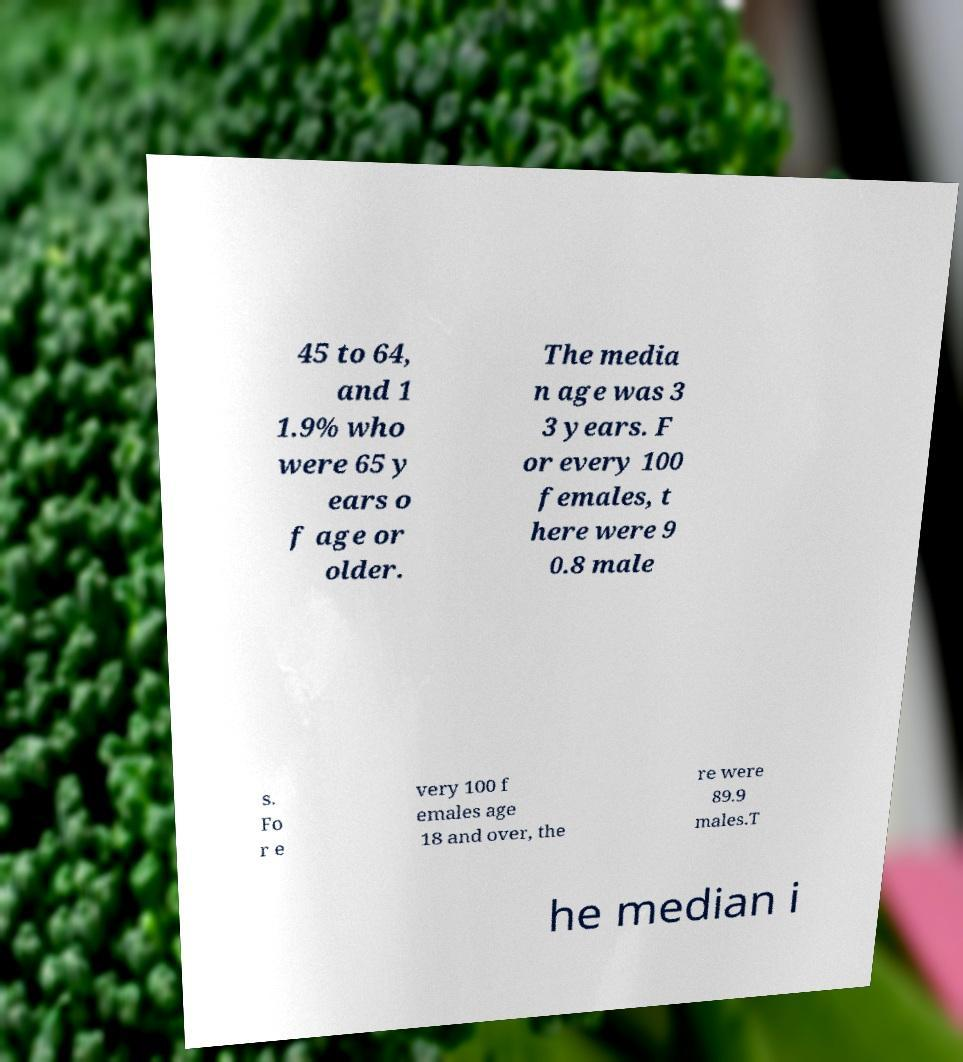Can you read and provide the text displayed in the image?This photo seems to have some interesting text. Can you extract and type it out for me? 45 to 64, and 1 1.9% who were 65 y ears o f age or older. The media n age was 3 3 years. F or every 100 females, t here were 9 0.8 male s. Fo r e very 100 f emales age 18 and over, the re were 89.9 males.T he median i 